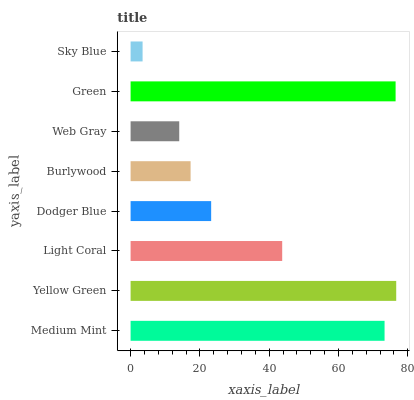Is Sky Blue the minimum?
Answer yes or no. Yes. Is Yellow Green the maximum?
Answer yes or no. Yes. Is Light Coral the minimum?
Answer yes or no. No. Is Light Coral the maximum?
Answer yes or no. No. Is Yellow Green greater than Light Coral?
Answer yes or no. Yes. Is Light Coral less than Yellow Green?
Answer yes or no. Yes. Is Light Coral greater than Yellow Green?
Answer yes or no. No. Is Yellow Green less than Light Coral?
Answer yes or no. No. Is Light Coral the high median?
Answer yes or no. Yes. Is Dodger Blue the low median?
Answer yes or no. Yes. Is Yellow Green the high median?
Answer yes or no. No. Is Green the low median?
Answer yes or no. No. 